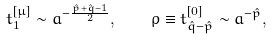Convert formula to latex. <formula><loc_0><loc_0><loc_500><loc_500>t ^ { [ \mu ] } _ { 1 } \sim a ^ { - \frac { \hat { p } + \hat { q } - 1 } { 2 } } , \quad \rho \equiv t ^ { [ 0 ] } _ { \hat { q } - \hat { p } } \sim a ^ { - \hat { p } } ,</formula> 